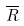Convert formula to latex. <formula><loc_0><loc_0><loc_500><loc_500>\overline { R }</formula> 